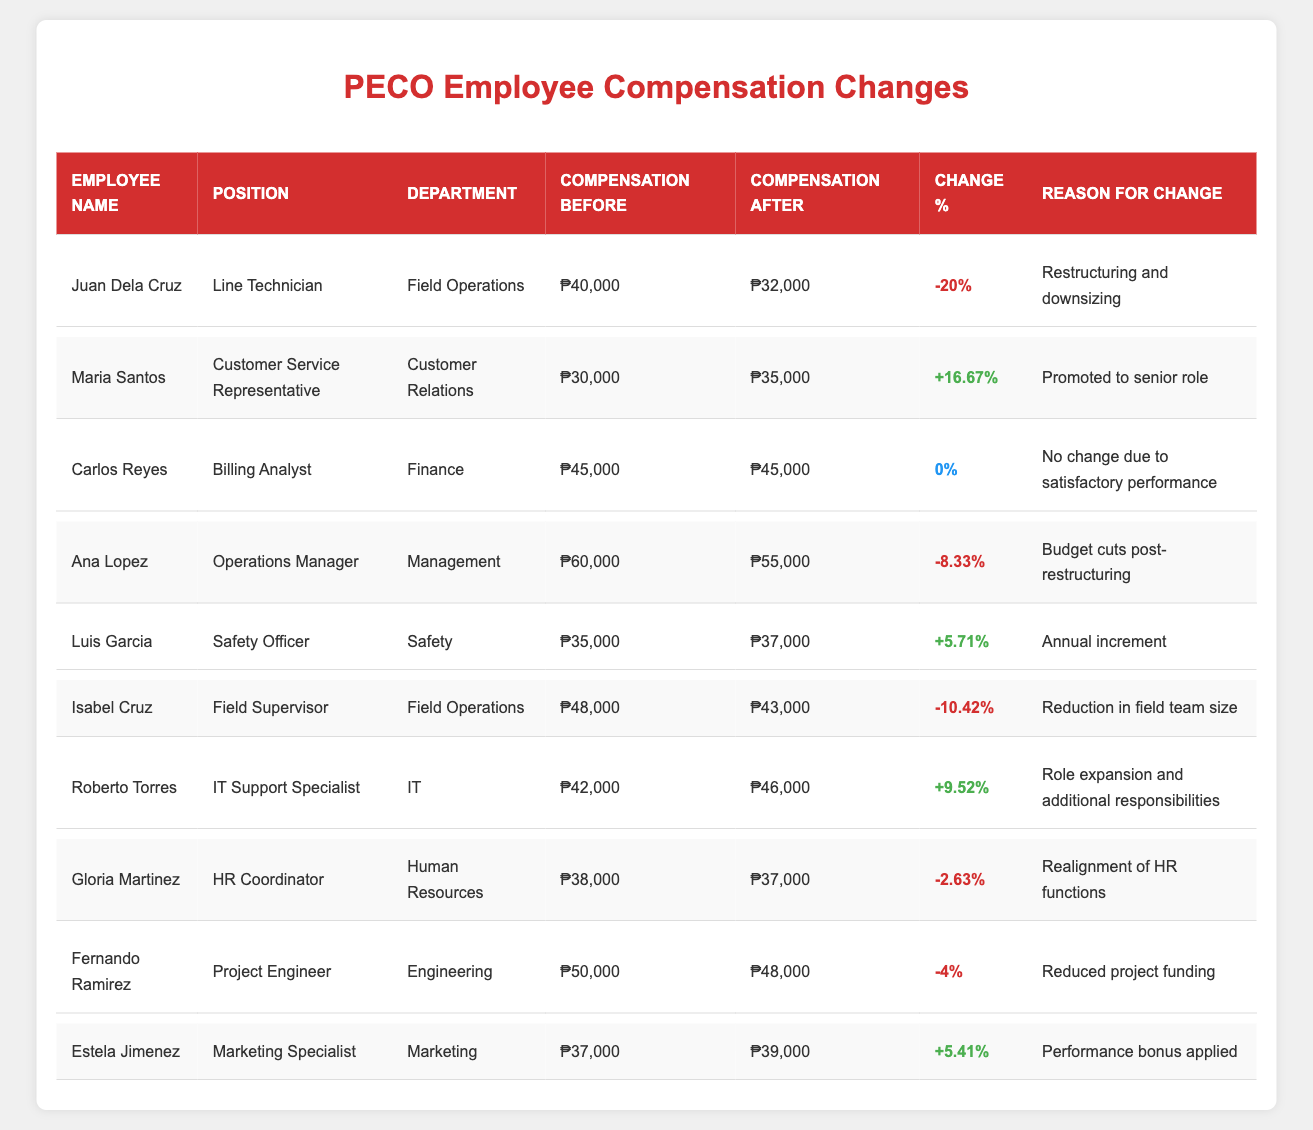What was the compensation change for Juan Dela Cruz? Juan Dela Cruz's compensation before was ₱40,000, and after the restructuring, it is ₱32,000. The change percentage is -20%.
Answer: -20% How much was Maria Santos's compensation after her promotion? Maria Santos's compensation after her promotion is ₱35,000.
Answer: ₱35,000 Which employee experienced the largest decrease in compensation? Juan Dela Cruz had the largest decrease in compensation, dropping from ₱40,000 to ₱32,000, a change of -20%.
Answer: Juan Dela Cruz What percentage increase did Roberto Torres receive? Roberto Torres's compensation increased from ₱42,000 to ₱46,000. The percentage increase is calculated as ((46,000 - 42,000) / 42,000) * 100 = 9.52%.
Answer: 9.52% Were there any employees whose compensation remained the same after restructuring? Yes, Carlos Reyes's compensation remained the same at ₱45,000 after restructuring.
Answer: Yes What is the average compensation change percentage for all employees? Total change percentages: -20 + 16.67 + 0 - 8.33 + 5.71 - 10.42 + 9.52 - 2.63 - 4 = -14.48. There are 10 employees, so the average is -14.48 / 10 = -1.448%.
Answer: -1.448% How many employees received a compensation increase? The employees who received a compensation increase are Maria Santos (16.67%), Luis Garcia (5.71%), Roberto Torres (9.52%), and Estela Jimenez (5.41%), totaling four employees.
Answer: 4 What was the compensation for the Employee ID E004 before restructuring? Employee ID E004, Ana Lopez, had a compensation of ₱60,000 before restructuring.
Answer: ₱60,000 Did Isabel Cruz's compensation decrease after restructuring? Yes, Isabel Cruz's compensation decreased from ₱48,000 to ₱43,000, a change of -10.42%.
Answer: Yes How do the total compensations before restructuring compare to those after for the entire company? Total compensation before restructuring: ₱40,000 + ₱30,000 + ₱45,000 + ₱60,000 + ₱35,000 + ₱48,000 + ₱42,000 + ₱38,000 + ₱50,000 + ₱37,000 = ₱425,000. After restructuring: ₱32,000 + ₱35,000 + ₱45,000 + ₱55,000 + ₱37,000 + ₱43,000 + ₱46,000 + ₱37,000 + ₱48,000 + ₱39,000 = ₱417,000. Hence, total before is greater than after by ₱8,000.
Answer: Total before is greater by ₱8,000 